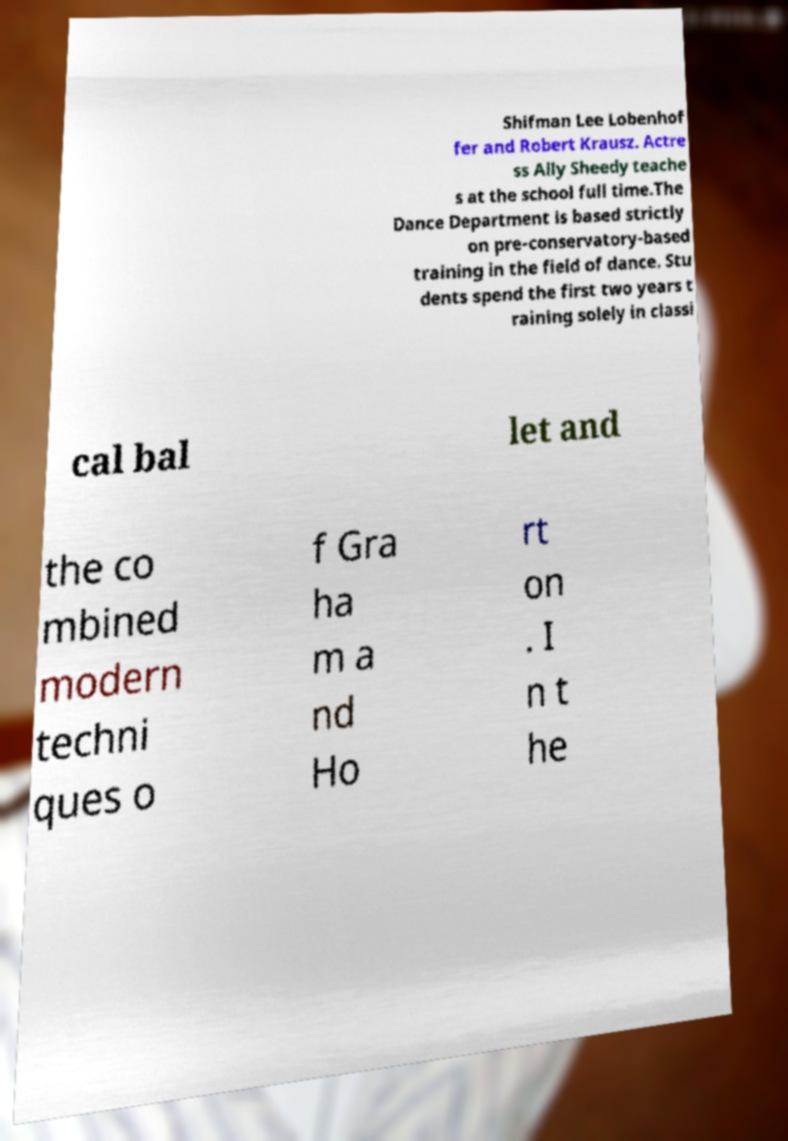Can you accurately transcribe the text from the provided image for me? Shifman Lee Lobenhof fer and Robert Krausz. Actre ss Ally Sheedy teache s at the school full time.The Dance Department is based strictly on pre-conservatory-based training in the field of dance. Stu dents spend the first two years t raining solely in classi cal bal let and the co mbined modern techni ques o f Gra ha m a nd Ho rt on . I n t he 